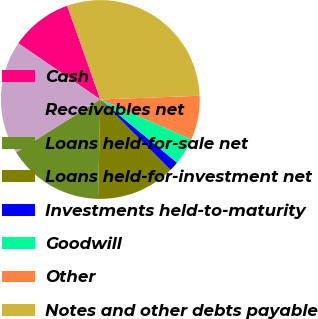<chart> <loc_0><loc_0><loc_500><loc_500><pie_chart><fcel>Cash<fcel>Receivables net<fcel>Loans held-for-sale net<fcel>Loans held-for-investment net<fcel>Investments held-to-maturity<fcel>Goodwill<fcel>Other<fcel>Notes and other debts payable<nl><fcel>10.03%<fcel>18.51%<fcel>15.68%<fcel>12.85%<fcel>1.55%<fcel>4.37%<fcel>7.2%<fcel>29.82%<nl></chart> 